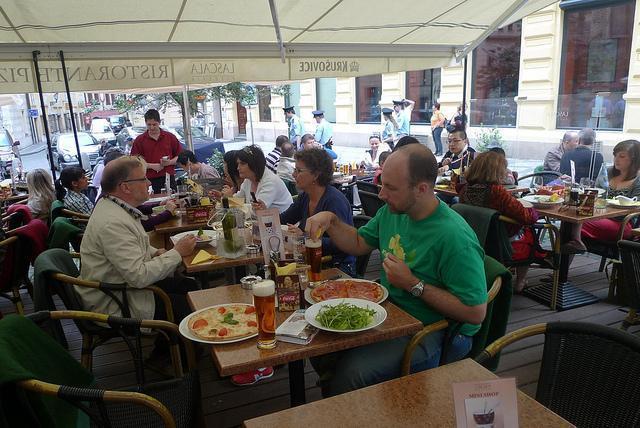How many people can be seen?
Give a very brief answer. 7. How many dining tables can you see?
Give a very brief answer. 3. How many chairs are in the photo?
Give a very brief answer. 5. How many bowls are in the photo?
Give a very brief answer. 1. How many pizzas are in the picture?
Give a very brief answer. 1. How many clocks are in the photo?
Give a very brief answer. 0. 